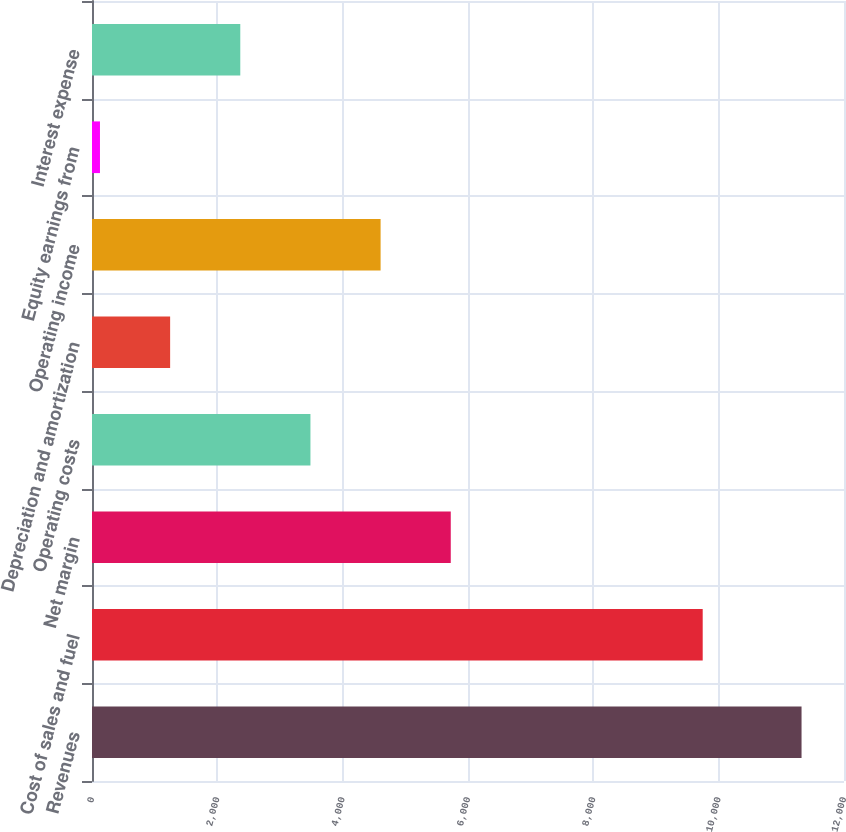Convert chart to OTSL. <chart><loc_0><loc_0><loc_500><loc_500><bar_chart><fcel>Revenues<fcel>Cost of sales and fuel<fcel>Net margin<fcel>Operating costs<fcel>Depreciation and amortization<fcel>Operating income<fcel>Equity earnings from<fcel>Interest expense<nl><fcel>11322.6<fcel>9745.2<fcel>5724.9<fcel>3485.82<fcel>1246.74<fcel>4605.36<fcel>127.2<fcel>2366.28<nl></chart> 